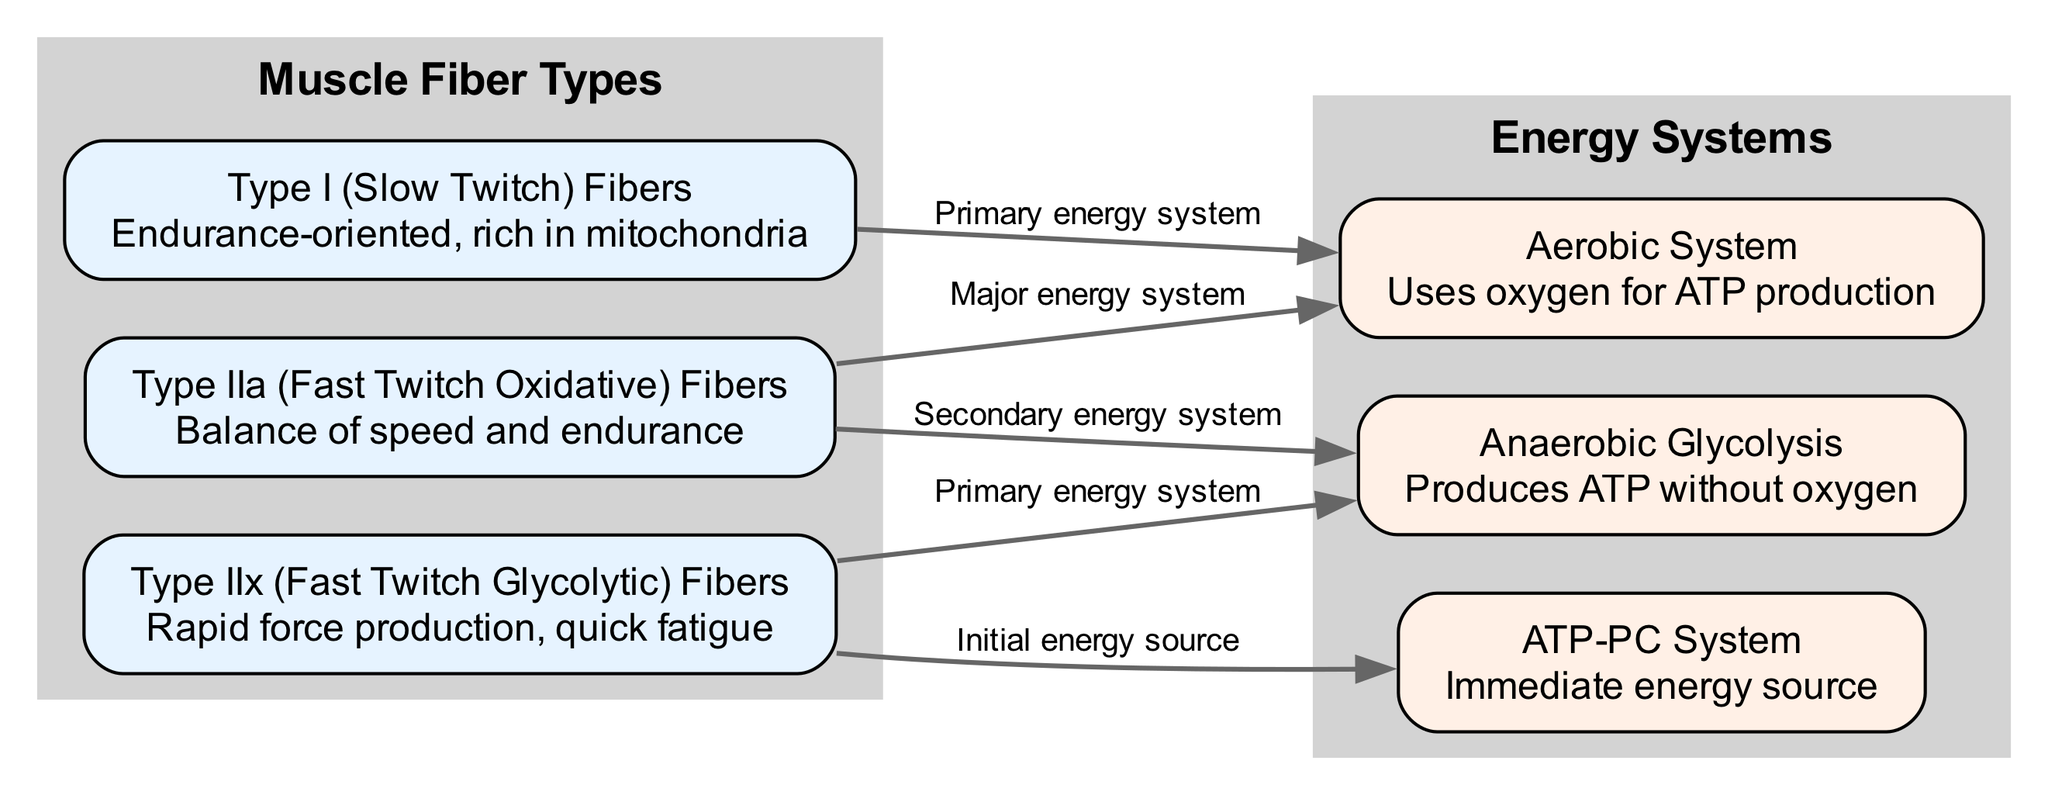What are the three types of muscle fibers depicted in the diagram? The diagram includes three nodes representing muscle fiber types: Type I, Type IIa, and Type IIx. These are explicitly labeled in the nodes of the graphic, summarizing the muscle fiber types clearly.
Answer: Type I, Type IIa, Type IIx Which energy system primarily serves Type I fibers? The diagram shows an edge leading from the Type I fibers node to the Aerobic System node, with a label indicating this is the primary energy system for Type I fibers. This is represented visually with a clear connection.
Answer: Aerobic System How many edges are indicated in the diagram? By counting the connections made between the nodes in the diagram, there are a total of five edges connecting the muscle fiber types with energy systems.
Answer: Five What is the primary energy system for Type IIx fibers? The diagram indicates a connection from the Type IIx fibers to the Anaerobic Glycolysis node, labeled as the primary energy system for those fibers. This direct relationship is noted in the edge between these two nodes.
Answer: Anaerobic Glycolysis Which fiber type is characterized by speed and endurance? The diagram describes Type IIa fibers as providing a balance of speed and endurance based on their node description. This specific detail clearly identifies the characteristics of Type IIa fibers.
Answer: Type IIa Fibers What initial energy source is utilized by Type IIx fibers? The connection from Type IIx fibers to the ATP-PC System indicates that this system serves as the initial energy source for Type IIx fibers, as noted in the edge description connecting these two nodes.
Answer: ATP-PC System How many groups are represented in the diagram? There are two distinct groups represented in the diagram: one for Muscle Fiber Types and another for Energy Systems. These groups are depicted as separate clusters, each containing relevant nodes associated with their category.
Answer: Two Which muscle fiber type is most conducive to endurance activities? The Type I fibers are described as being endurance-oriented and rich in mitochondria, which signifies their suitability for longer-duration activities when assessing their characteristics in the diagram.
Answer: Type I Fibers 